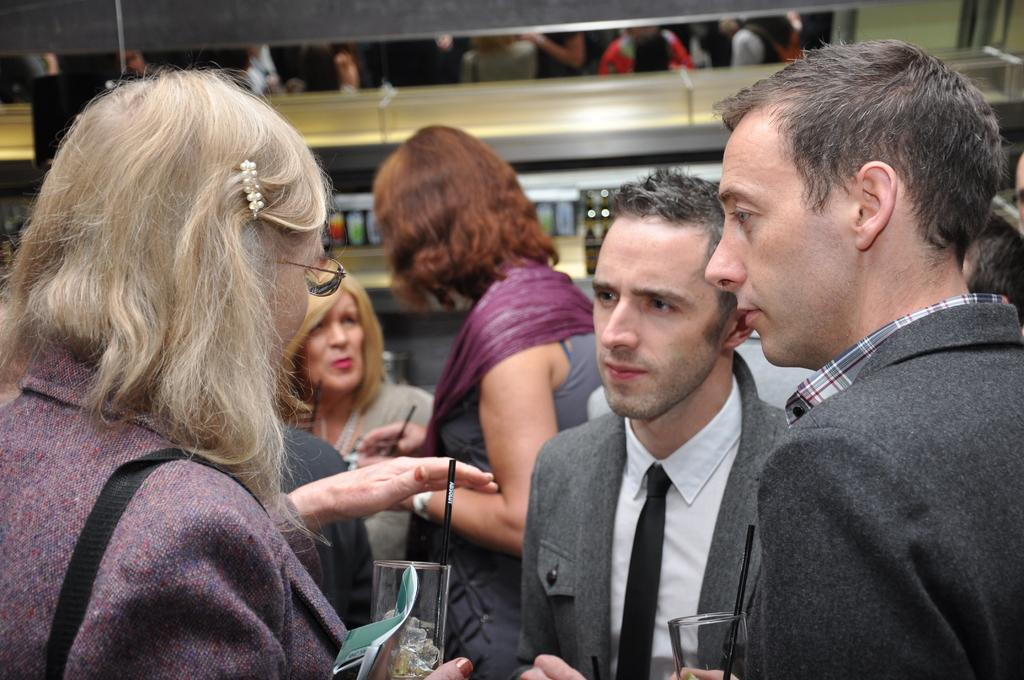What are the people in the image doing? The people in the image are standing and holding glasses. What can be seen in the background of the image? There is a wall in the background of the image. What type of waves can be seen crashing against the buildings in the image? There are no waves or buildings present in the image; it features people standing and holding glasses with a wall in the background. 